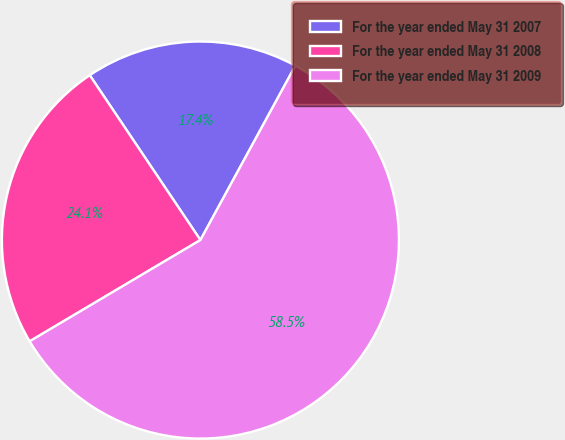Convert chart to OTSL. <chart><loc_0><loc_0><loc_500><loc_500><pie_chart><fcel>For the year ended May 31 2007<fcel>For the year ended May 31 2008<fcel>For the year ended May 31 2009<nl><fcel>17.35%<fcel>24.11%<fcel>58.54%<nl></chart> 